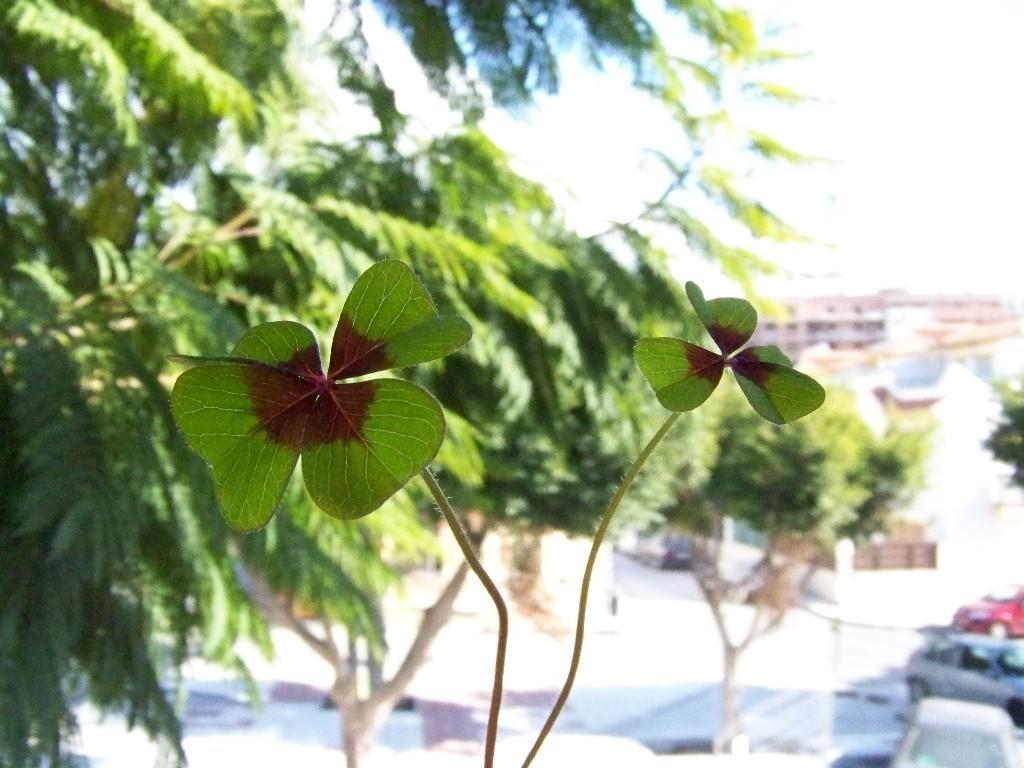Could you give a brief overview of what you see in this image? In this picture there are few leaves of a plant which has red color in between it and there is a tree in the left corner and there are few buildings and vehicles in the right corner. 